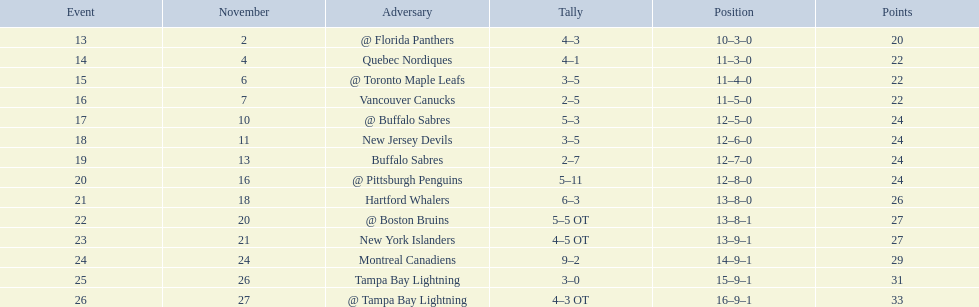What were the scores of the 1993-94 philadelphia flyers season? 4–3, 4–1, 3–5, 2–5, 5–3, 3–5, 2–7, 5–11, 6–3, 5–5 OT, 4–5 OT, 9–2, 3–0, 4–3 OT. Which of these teams had the score 4-5 ot? New York Islanders. 